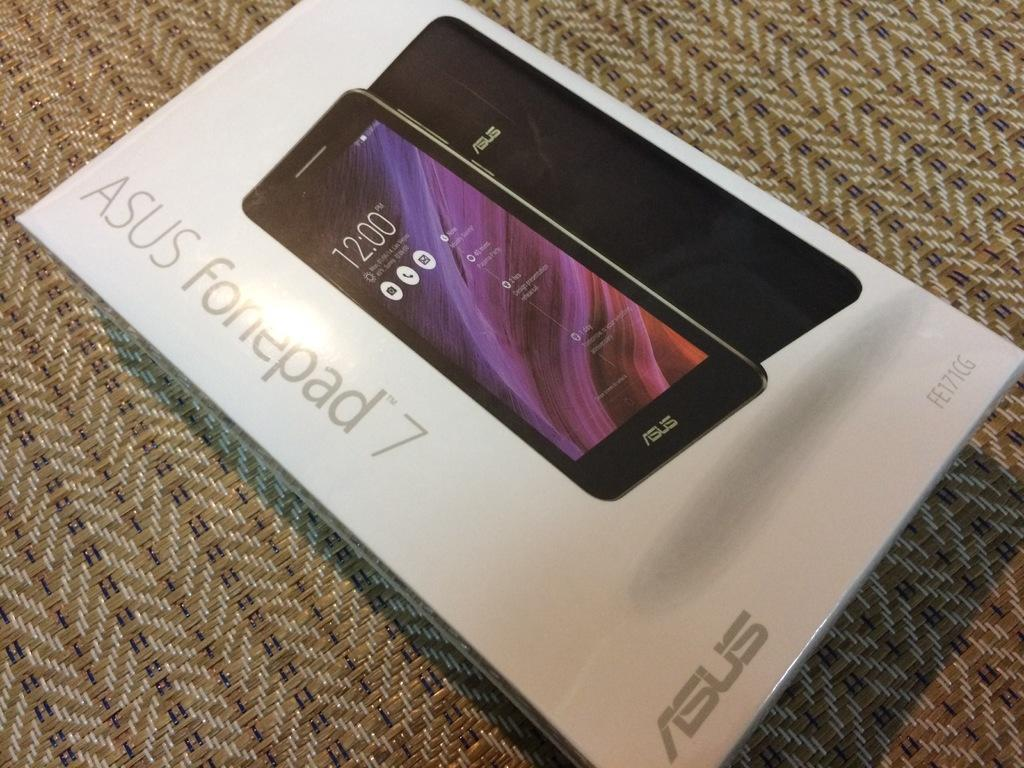<image>
Share a concise interpretation of the image provided. The box for an Asus brand Fonepad 7. 